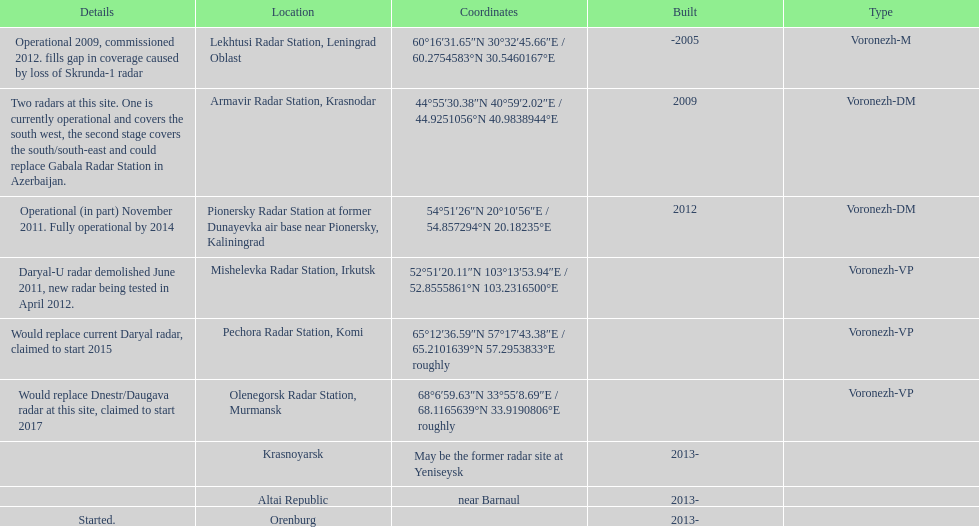How long did it take the pionersky radar station to go from partially operational to fully operational? 3 years. 